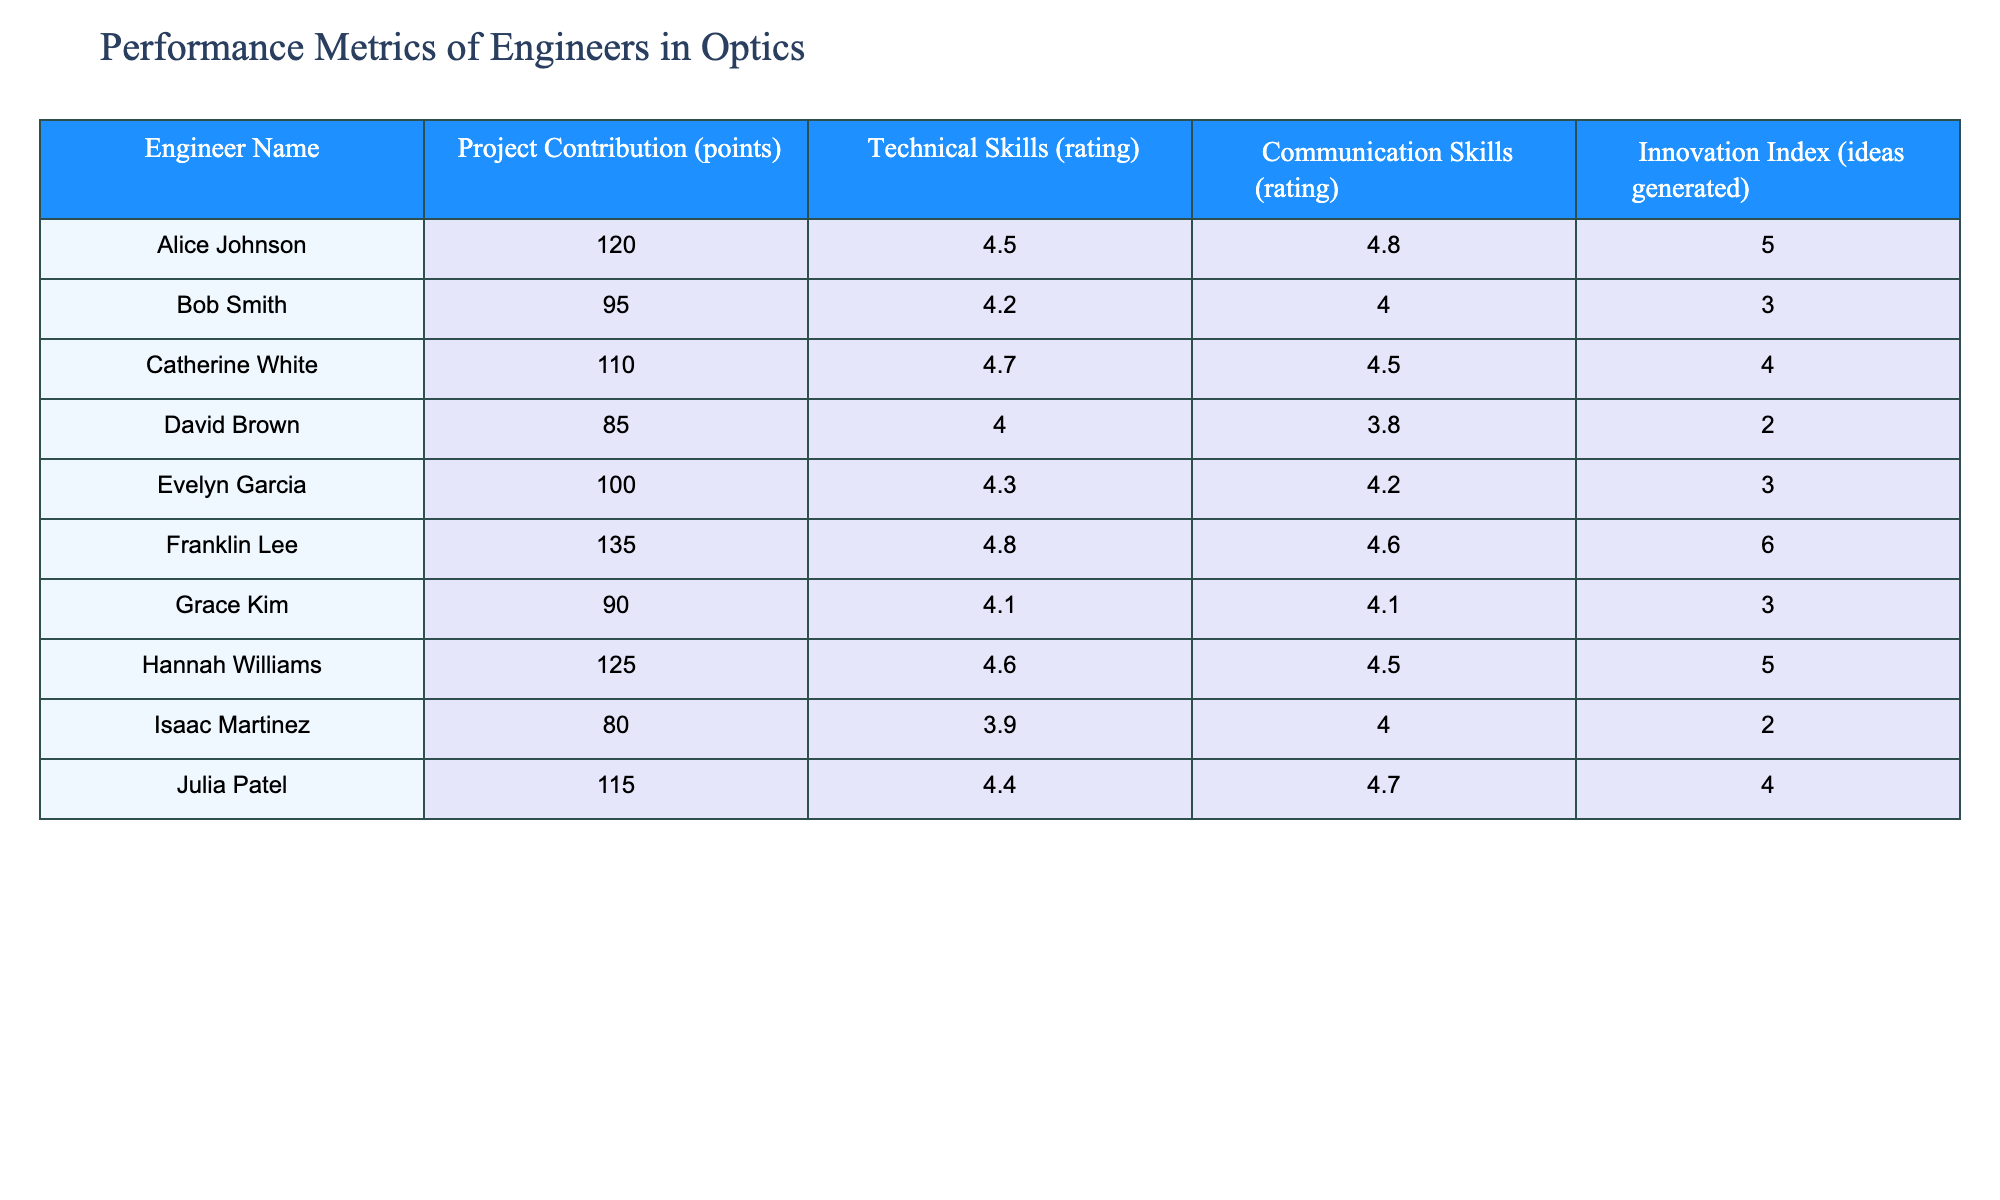What is the highest Project Contribution score? By examining the Project Contribution column, we find that the highest score is 135, which belongs to Franklin Lee.
Answer: 135 Which engineer has the lowest Communication Skills rating? Looking through the Communication Skills column, we see that Isaac Martinez has the lowest rating of 4.0 compared to the others.
Answer: Isaac Martinez What is the average Innovation Index across all engineers? We sum the Innovation Index scores: 5 + 3 + 4 + 2 + 3 + 6 + 3 + 5 + 2 + 4 = 43, and since there are 10 engineers, we divide this by 10: 43/10 = 4.3.
Answer: 4.3 Is Alice Johnson rated higher in Technical Skills than Bob Smith? Comparing the Technical Skills ratings, Alice Johnson has 4.5 and Bob Smith has 4.2. Since 4.5 is greater than 4.2, Alice Johnson is rated higher.
Answer: Yes What is the difference between the highest and lowest Project Contribution scores? The highest score is 135 (Franklin Lee) and the lowest is 80 (Isaac Martinez). Thus, the difference is 135 - 80 = 55.
Answer: 55 Which engineer generated the most ideas in the Innovation Index? Observing the Innovation Index, Franklin Lee has the highest score of 6, making him the engineer who generated the most ideas.
Answer: Franklin Lee How many engineers have a Technical Skills rating of 4.4 or higher? The ratings of engineers with 4.4 or higher are Alice Johnson, Catherine White, Franklin Lee, Julia Patel, and Hannah Williams, totaling 5 engineers.
Answer: 5 What percentage of engineers have a Communication Skills rating above 4.5? The engineers with ratings above 4.5 are Alice Johnson, Catherine White, Franklin Lee, and Hannah Williams, making 4 out of 10 engineers. The percentage is (4/10) * 100 = 40%.
Answer: 40% 